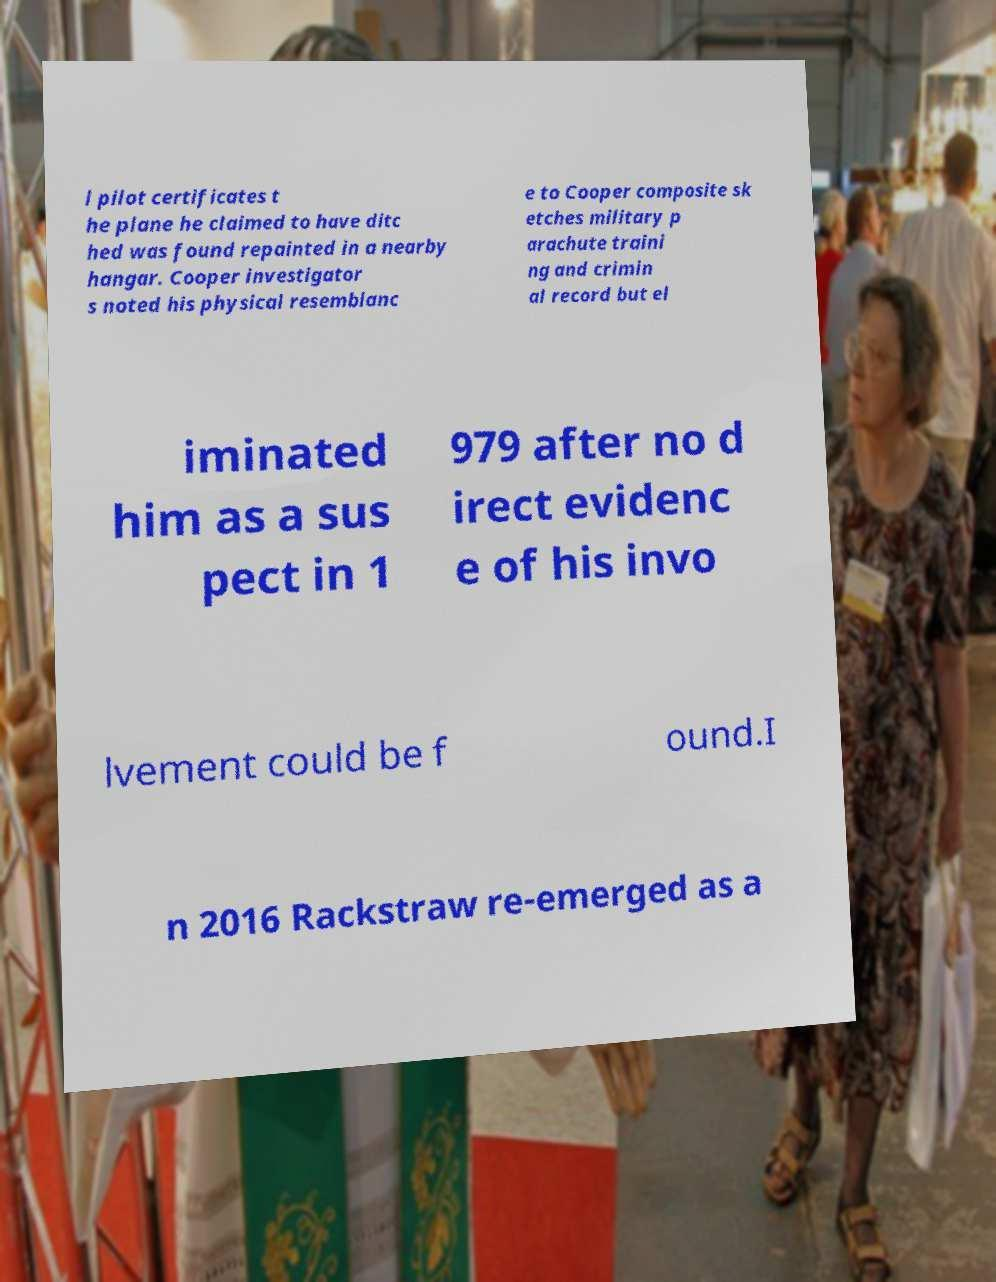Could you assist in decoding the text presented in this image and type it out clearly? l pilot certificates t he plane he claimed to have ditc hed was found repainted in a nearby hangar. Cooper investigator s noted his physical resemblanc e to Cooper composite sk etches military p arachute traini ng and crimin al record but el iminated him as a sus pect in 1 979 after no d irect evidenc e of his invo lvement could be f ound.I n 2016 Rackstraw re-emerged as a 